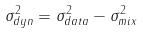<formula> <loc_0><loc_0><loc_500><loc_500>\sigma ^ { 2 } _ { d y n } = \sigma ^ { 2 } _ { d a t a } - \sigma ^ { 2 } _ { m i x }</formula> 